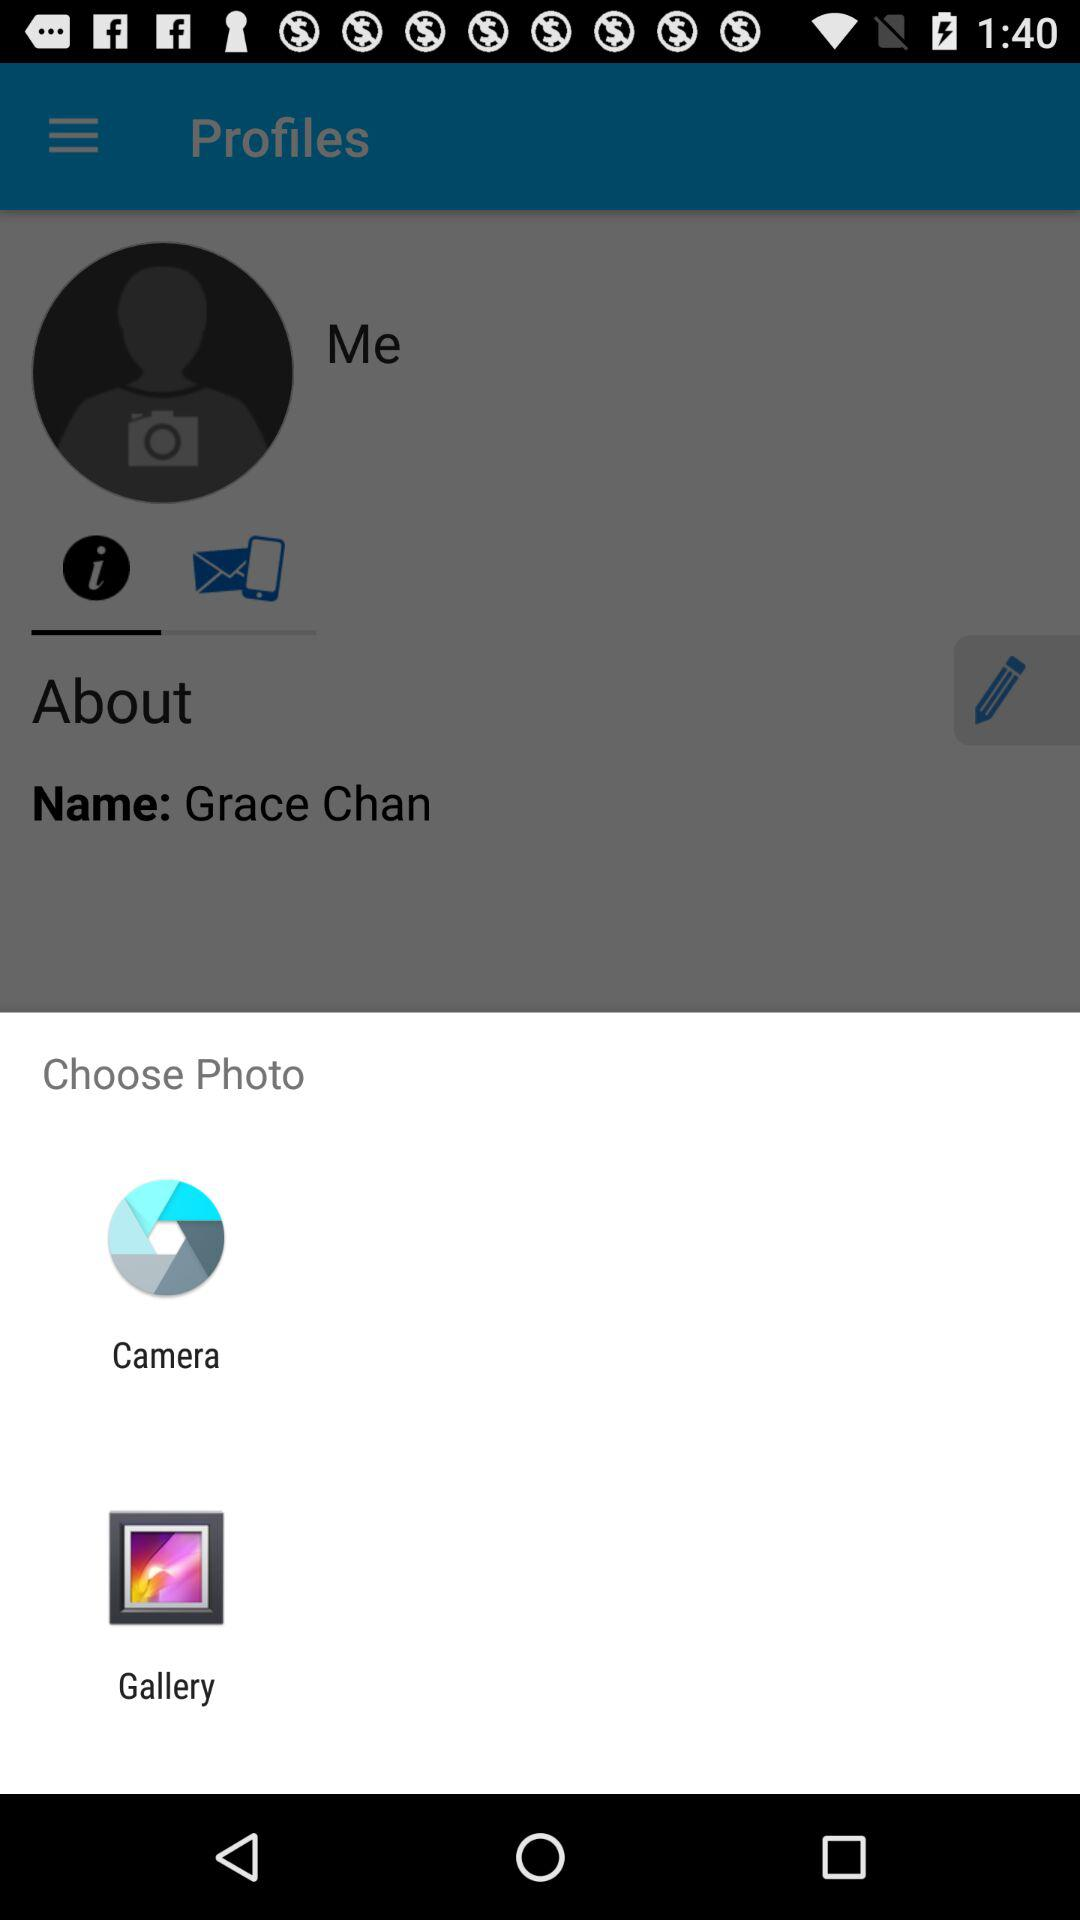What are the two options to select a photo from? The two options to select a photo are the camera and gallery. 